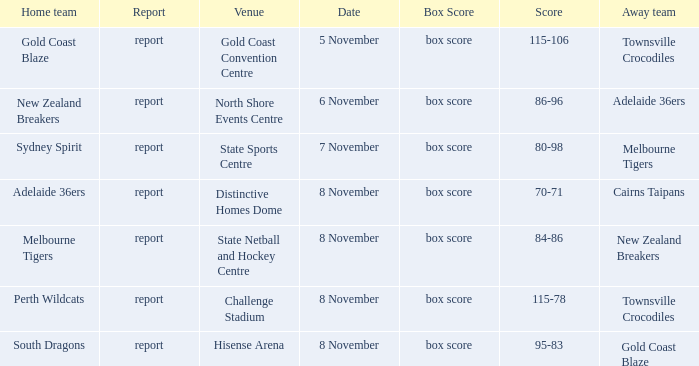What was the date that featured a game against Gold Coast Blaze? 8 November. 